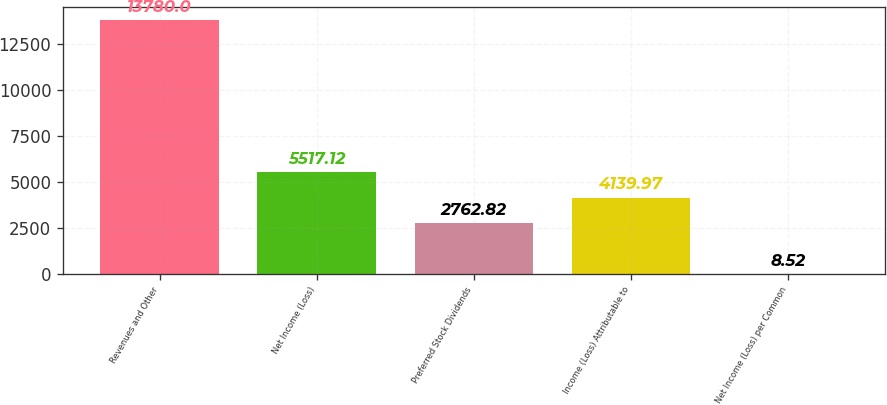Convert chart to OTSL. <chart><loc_0><loc_0><loc_500><loc_500><bar_chart><fcel>Revenues and Other<fcel>Net Income (Loss)<fcel>Preferred Stock Dividends<fcel>Income (Loss) Attributable to<fcel>Net Income (Loss) per Common<nl><fcel>13780<fcel>5517.12<fcel>2762.82<fcel>4139.97<fcel>8.52<nl></chart> 